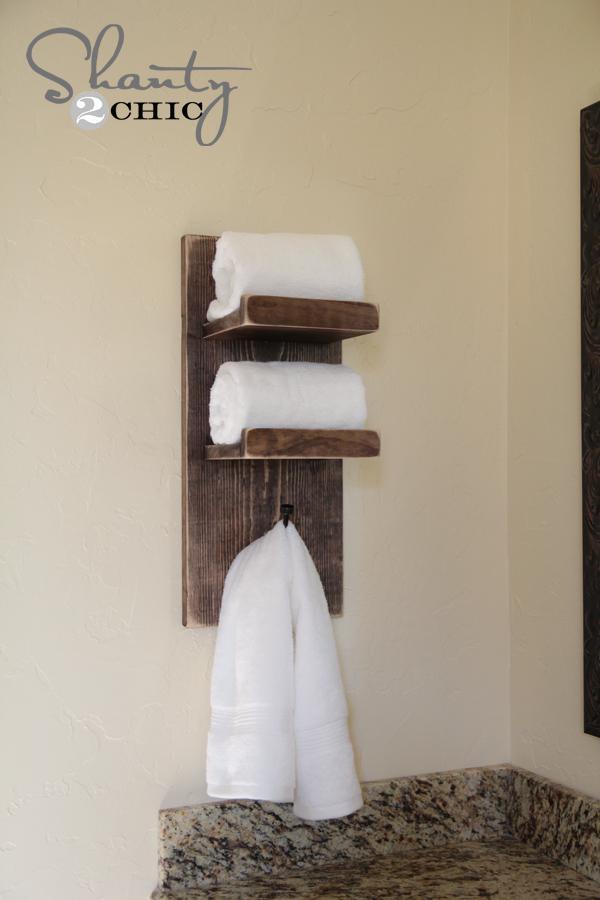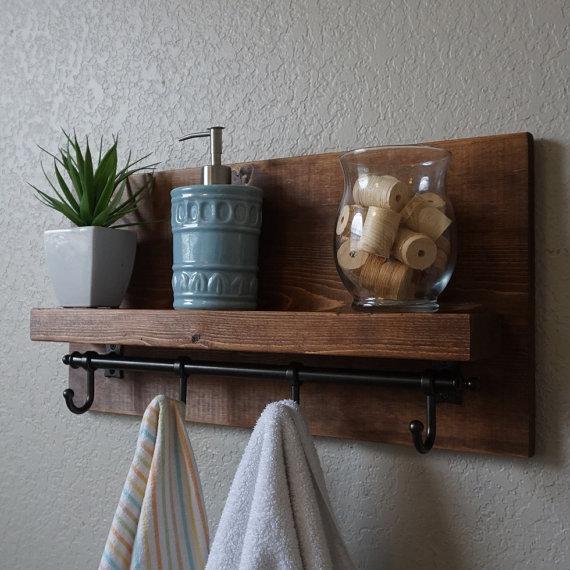The first image is the image on the left, the second image is the image on the right. Considering the images on both sides, is "An image shows towels draped on hooks beneath a shelf containing a plant, jar of spools, and blue pump dispenser." valid? Answer yes or no. Yes. The first image is the image on the left, the second image is the image on the right. Examine the images to the left and right. Is the description "All wooden bathroom shelves are stained dark and open on both ends, with no side enclosure boards." accurate? Answer yes or no. Yes. 